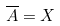<formula> <loc_0><loc_0><loc_500><loc_500>\overline { A } = X</formula> 